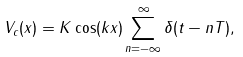Convert formula to latex. <formula><loc_0><loc_0><loc_500><loc_500>V _ { c } ( x ) = K \cos ( k x ) \sum _ { n = - \infty } ^ { \infty } \delta ( t - n T ) ,</formula> 